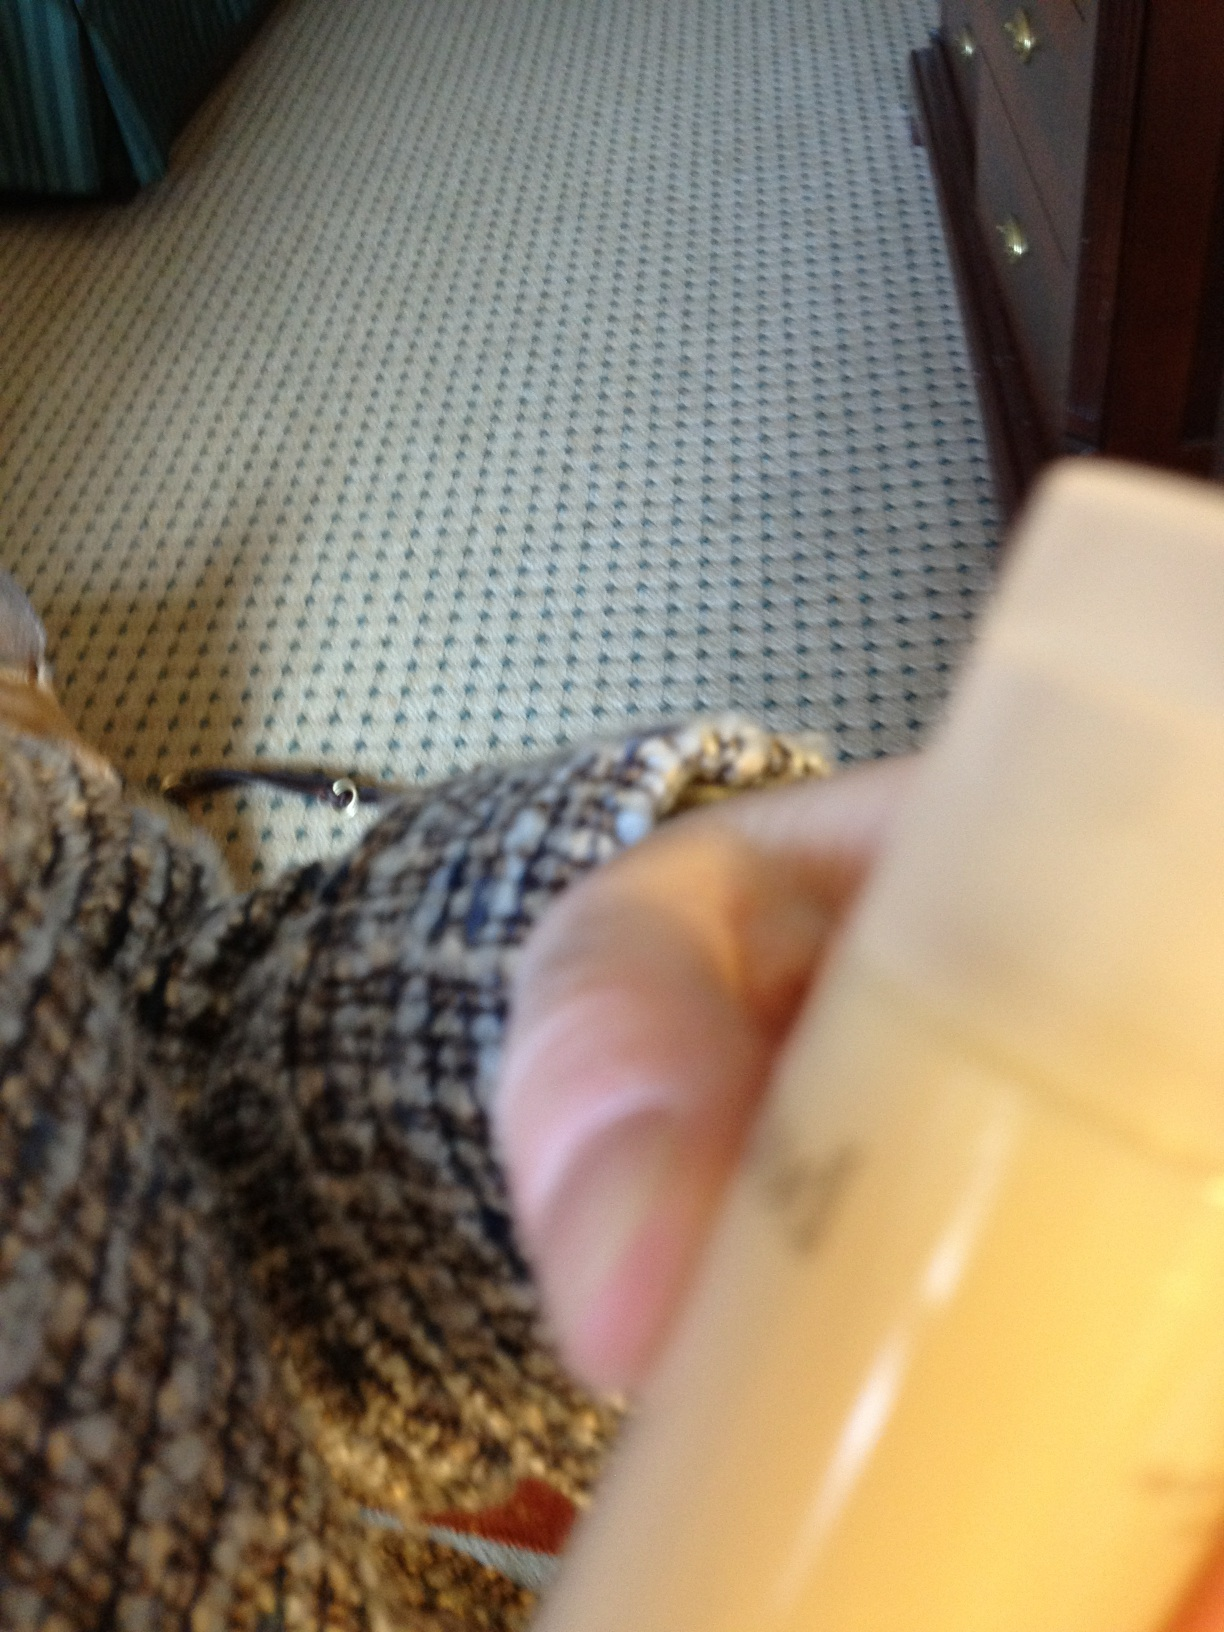Hi, can you tell me if this is shampoo or conditioner or what it is? Thank you. It's difficult to confirm instead from this image alone as the label is not visible, but based on the details of the container, it appears to be a personal care product, most likely a lotion or a personal care cream rather than a shampoo or conditioner. Shampoos and conditioners usually have more descriptive and visible branding. 